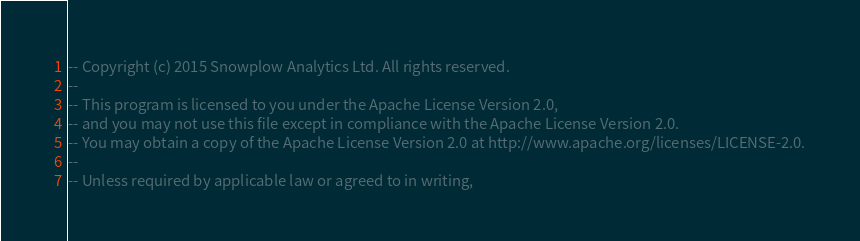<code> <loc_0><loc_0><loc_500><loc_500><_SQL_>-- Copyright (c) 2015 Snowplow Analytics Ltd. All rights reserved.
--
-- This program is licensed to you under the Apache License Version 2.0,
-- and you may not use this file except in compliance with the Apache License Version 2.0.
-- You may obtain a copy of the Apache License Version 2.0 at http://www.apache.org/licenses/LICENSE-2.0.
--
-- Unless required by applicable law or agreed to in writing,</code> 